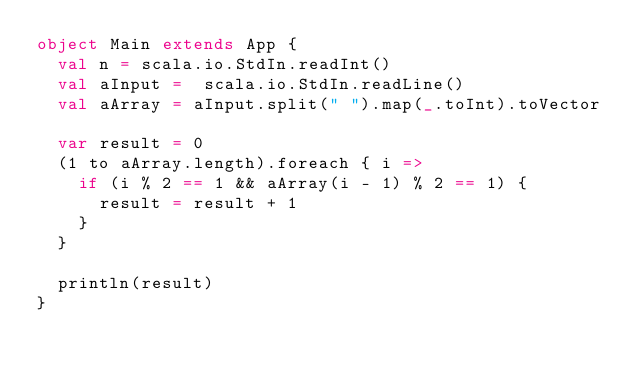<code> <loc_0><loc_0><loc_500><loc_500><_Scala_>object Main extends App {
  val n = scala.io.StdIn.readInt()
  val aInput =  scala.io.StdIn.readLine()
  val aArray = aInput.split(" ").map(_.toInt).toVector

  var result = 0
  (1 to aArray.length).foreach { i =>
    if (i % 2 == 1 && aArray(i - 1) % 2 == 1) {
      result = result + 1
    }
  }

  println(result)
}</code> 